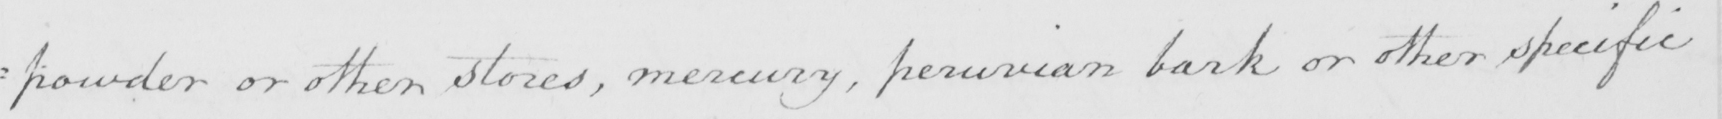Please transcribe the handwritten text in this image. : powder or other stores , mercury , peruvian bark or other specific 